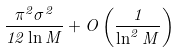Convert formula to latex. <formula><loc_0><loc_0><loc_500><loc_500>\frac { \pi ^ { 2 } \sigma ^ { 2 } } { 1 2 \ln M } + O \left ( \frac { 1 } { \ln ^ { 2 } M } \right )</formula> 